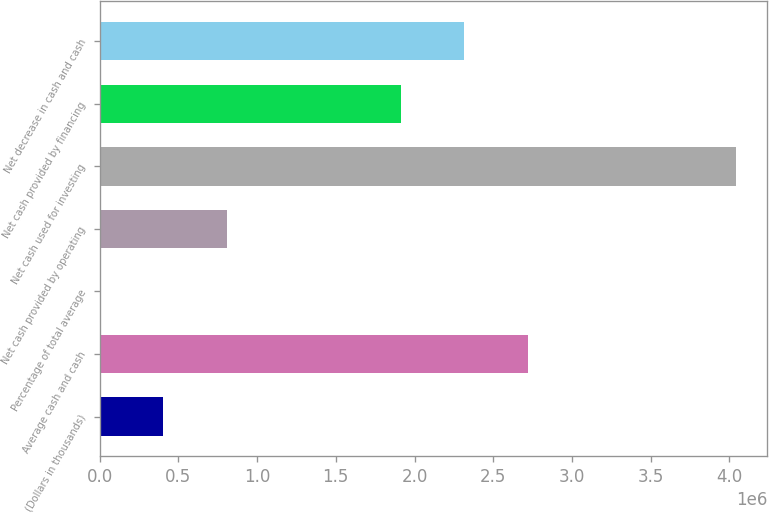Convert chart. <chart><loc_0><loc_0><loc_500><loc_500><bar_chart><fcel>(Dollars in thousands)<fcel>Average cash and cash<fcel>Percentage of total average<fcel>Net cash provided by operating<fcel>Net cash used for investing<fcel>Net cash provided by financing<fcel>Net decrease in cash and cash<nl><fcel>403896<fcel>2.71885e+06<fcel>12.1<fcel>807780<fcel>4.03885e+06<fcel>1.91108e+06<fcel>2.31496e+06<nl></chart> 